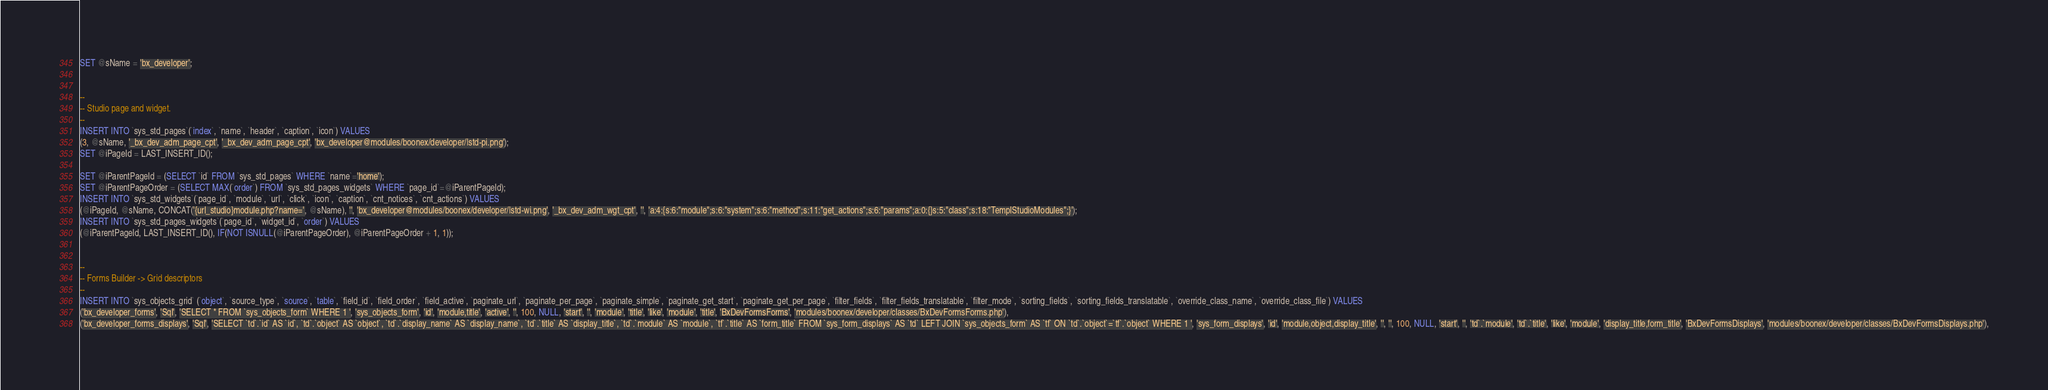<code> <loc_0><loc_0><loc_500><loc_500><_SQL_>SET @sName = 'bx_developer';


--
-- Studio page and widget.
--
INSERT INTO `sys_std_pages`(`index`, `name`, `header`, `caption`, `icon`) VALUES
(3, @sName, '_bx_dev_adm_page_cpt', '_bx_dev_adm_page_cpt', 'bx_developer@modules/boonex/developer/|std-pi.png');
SET @iPageId = LAST_INSERT_ID();

SET @iParentPageId = (SELECT `id` FROM `sys_std_pages` WHERE `name`='home');
SET @iParentPageOrder = (SELECT MAX(`order`) FROM `sys_std_pages_widgets` WHERE `page_id`=@iParentPageId);
INSERT INTO `sys_std_widgets`(`page_id`, `module`, `url`, `click`, `icon`, `caption`, `cnt_notices`, `cnt_actions`) VALUES
(@iPageId, @sName, CONCAT('{url_studio}module.php?name=', @sName), '', 'bx_developer@modules/boonex/developer/|std-wi.png', '_bx_dev_adm_wgt_cpt', '', 'a:4:{s:6:"module";s:6:"system";s:6:"method";s:11:"get_actions";s:6:"params";a:0:{}s:5:"class";s:18:"TemplStudioModules";}');
INSERT INTO `sys_std_pages_widgets`(`page_id`, `widget_id`, `order`) VALUES
(@iParentPageId, LAST_INSERT_ID(), IF(NOT ISNULL(@iParentPageOrder), @iParentPageOrder + 1, 1));


--
-- Forms Builder -> Grid descriptors
--
INSERT INTO `sys_objects_grid` (`object`, `source_type`, `source`, `table`, `field_id`, `field_order`, `field_active`, `paginate_url`, `paginate_per_page`, `paginate_simple`, `paginate_get_start`, `paginate_get_per_page`, `filter_fields`, `filter_fields_translatable`, `filter_mode`, `sorting_fields`, `sorting_fields_translatable`, `override_class_name`, `override_class_file`) VALUES
('bx_developer_forms', 'Sql', 'SELECT * FROM `sys_objects_form` WHERE 1 ', 'sys_objects_form', 'id', 'module,title', 'active', '', 100, NULL, 'start', '', 'module', 'title', 'like', 'module', 'title', 'BxDevFormsForms', 'modules/boonex/developer/classes/BxDevFormsForms.php'),
('bx_developer_forms_displays', 'Sql', 'SELECT `td`.`id` AS `id`, `td`.`object` AS `object`, `td`.`display_name` AS `display_name`, `td`.`title` AS `display_title`, `td`.`module` AS `module`, `tf`.`title` AS `form_title` FROM `sys_form_displays` AS `td` LEFT JOIN `sys_objects_form` AS `tf` ON `td`.`object`=`tf`.`object` WHERE 1 ', 'sys_form_displays', 'id', 'module,object,display_title', '', '', 100, NULL, 'start', '', 'td`.`module', 'td`.`title', 'like', 'module', 'display_title,form_title', 'BxDevFormsDisplays', 'modules/boonex/developer/classes/BxDevFormsDisplays.php'),</code> 